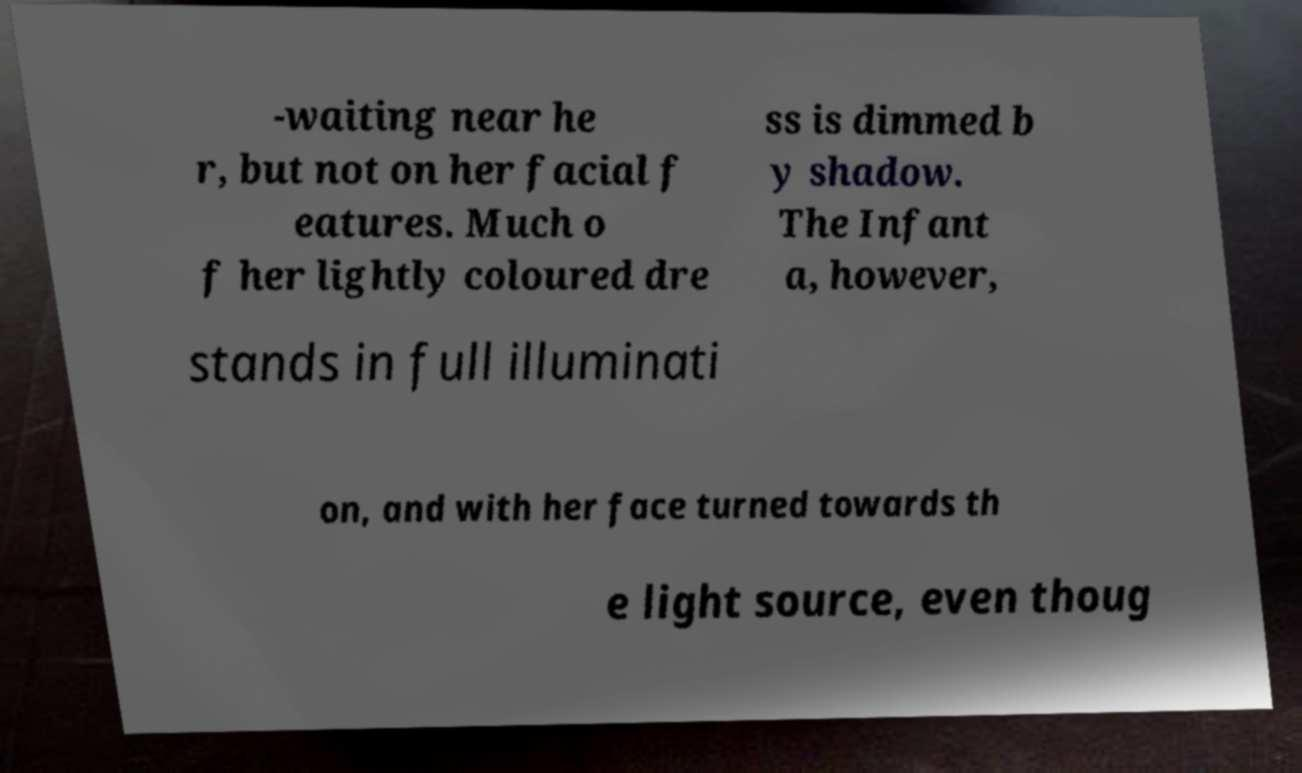Could you assist in decoding the text presented in this image and type it out clearly? -waiting near he r, but not on her facial f eatures. Much o f her lightly coloured dre ss is dimmed b y shadow. The Infant a, however, stands in full illuminati on, and with her face turned towards th e light source, even thoug 